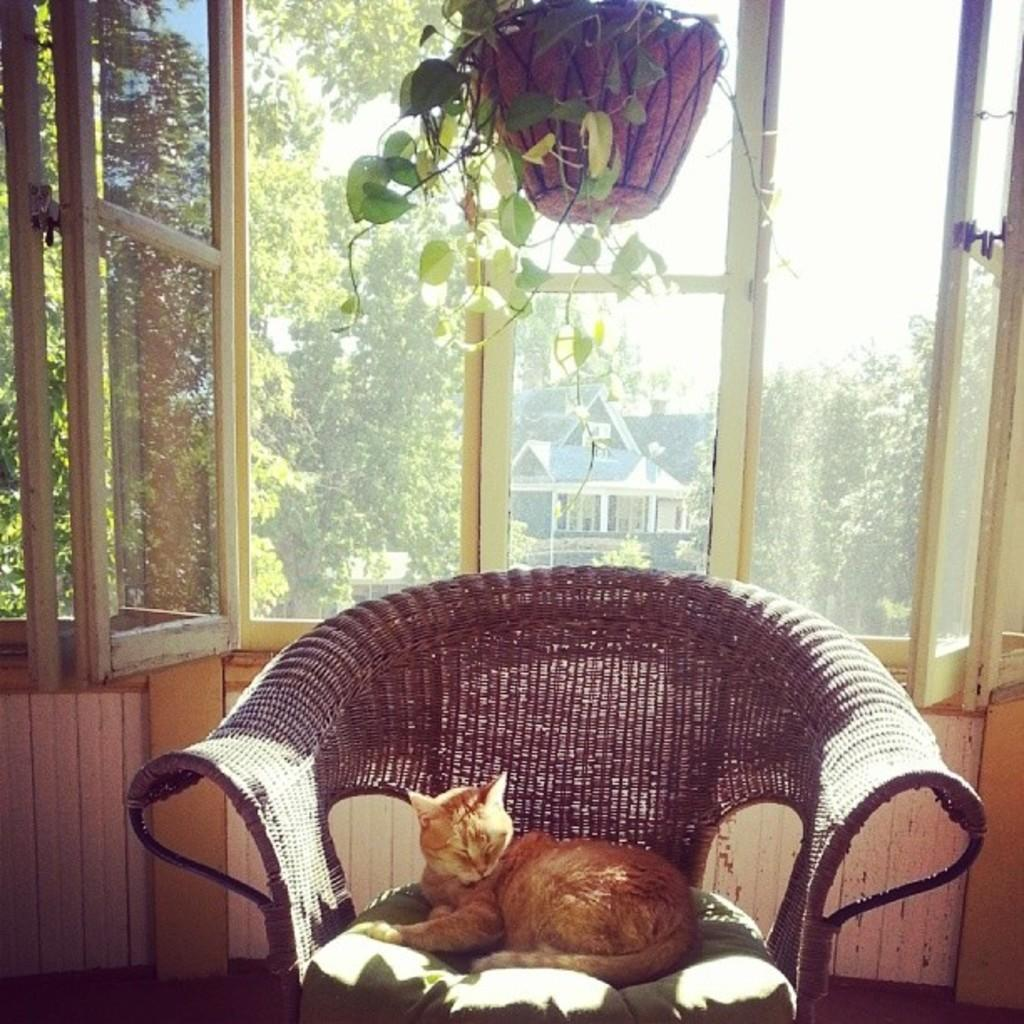What animal can be seen lying in the chair in the image? There is a cat lying in the chair in the image. What is visible in the background of the image? There is a window and a flower pot in the background. What can be seen through the window? Trees and a building are visible through the window. How many kittens are playing with the wind in the image? There are no kittens or wind present in the image. 